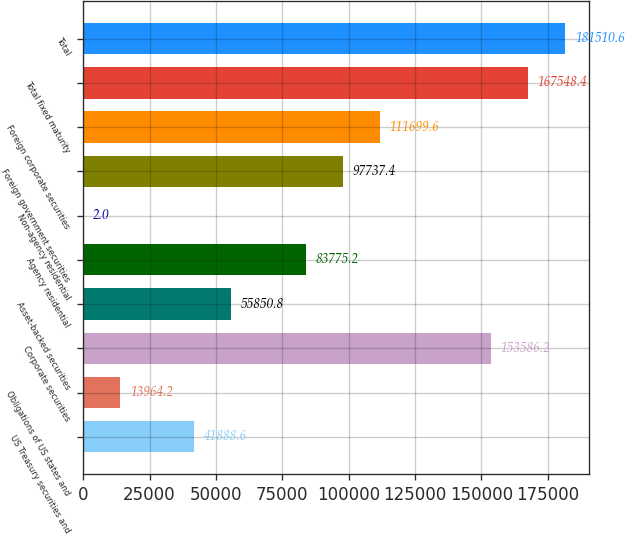Convert chart. <chart><loc_0><loc_0><loc_500><loc_500><bar_chart><fcel>US Treasury securities and<fcel>Obligations of US states and<fcel>Corporate securities<fcel>Asset-backed securities<fcel>Agency residential<fcel>Non-agency residential<fcel>Foreign government securities<fcel>Foreign corporate securities<fcel>Total fixed maturity<fcel>Total<nl><fcel>41888.6<fcel>13964.2<fcel>153586<fcel>55850.8<fcel>83775.2<fcel>2<fcel>97737.4<fcel>111700<fcel>167548<fcel>181511<nl></chart> 